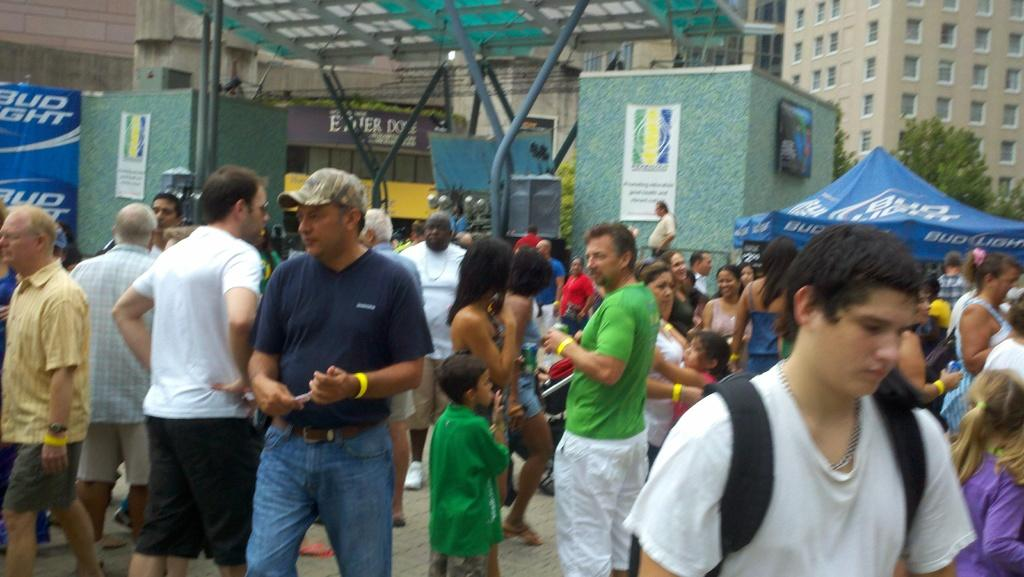Who or what can be seen in the image? There are people in the image. What structures are present in the image? There are poles, buildings, a tent, and a shed in the image. What type of vegetation is visible in the image? There are trees in the image. What is the ground like in the image? The ground is visible in the image. What additional items can be seen in the image? There are posters with text and images in the image. What is the price of the sky in the image? The sky does not have a price, as it is a natural element and not a purchasable item. What mark can be seen on the tent in the image? There is no mention of a mark on the tent in the provided facts, so it cannot be determined from the image. 